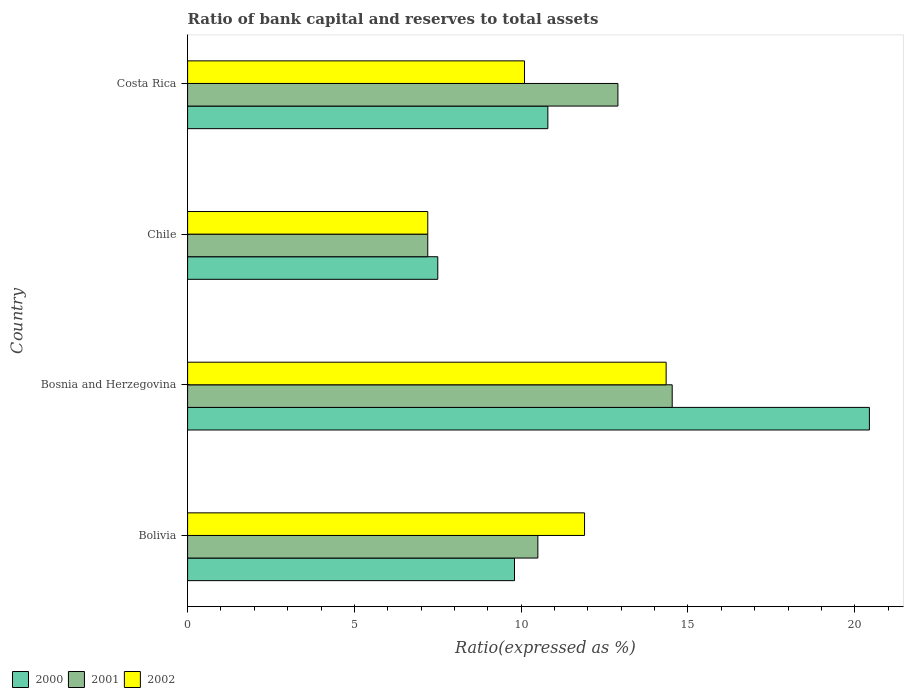How many different coloured bars are there?
Ensure brevity in your answer.  3. How many groups of bars are there?
Keep it short and to the point. 4. Are the number of bars per tick equal to the number of legend labels?
Keep it short and to the point. Yes. How many bars are there on the 4th tick from the bottom?
Keep it short and to the point. 3. What is the label of the 4th group of bars from the top?
Offer a terse response. Bolivia. What is the ratio of bank capital and reserves to total assets in 2000 in Chile?
Provide a short and direct response. 7.5. Across all countries, what is the maximum ratio of bank capital and reserves to total assets in 2002?
Offer a terse response. 14.35. In which country was the ratio of bank capital and reserves to total assets in 2000 maximum?
Keep it short and to the point. Bosnia and Herzegovina. What is the total ratio of bank capital and reserves to total assets in 2001 in the graph?
Ensure brevity in your answer.  45.13. What is the difference between the ratio of bank capital and reserves to total assets in 2000 in Bolivia and that in Costa Rica?
Provide a succinct answer. -1. What is the difference between the ratio of bank capital and reserves to total assets in 2001 in Bosnia and Herzegovina and the ratio of bank capital and reserves to total assets in 2000 in Chile?
Provide a short and direct response. 7.03. What is the average ratio of bank capital and reserves to total assets in 2000 per country?
Your answer should be very brief. 12.13. What is the difference between the ratio of bank capital and reserves to total assets in 2000 and ratio of bank capital and reserves to total assets in 2002 in Costa Rica?
Ensure brevity in your answer.  0.7. In how many countries, is the ratio of bank capital and reserves to total assets in 2000 greater than 15 %?
Ensure brevity in your answer.  1. What is the ratio of the ratio of bank capital and reserves to total assets in 2000 in Bosnia and Herzegovina to that in Costa Rica?
Make the answer very short. 1.89. What is the difference between the highest and the second highest ratio of bank capital and reserves to total assets in 2001?
Ensure brevity in your answer.  1.63. What is the difference between the highest and the lowest ratio of bank capital and reserves to total assets in 2001?
Offer a terse response. 7.33. What does the 1st bar from the top in Costa Rica represents?
Give a very brief answer. 2002. What does the 1st bar from the bottom in Chile represents?
Offer a very short reply. 2000. How many countries are there in the graph?
Your response must be concise. 4. What is the title of the graph?
Provide a short and direct response. Ratio of bank capital and reserves to total assets. What is the label or title of the X-axis?
Provide a succinct answer. Ratio(expressed as %). What is the label or title of the Y-axis?
Provide a short and direct response. Country. What is the Ratio(expressed as %) of 2000 in Bolivia?
Your answer should be compact. 9.8. What is the Ratio(expressed as %) of 2000 in Bosnia and Herzegovina?
Make the answer very short. 20.44. What is the Ratio(expressed as %) of 2001 in Bosnia and Herzegovina?
Your response must be concise. 14.53. What is the Ratio(expressed as %) in 2002 in Bosnia and Herzegovina?
Your answer should be very brief. 14.35. What is the Ratio(expressed as %) of 2002 in Chile?
Provide a succinct answer. 7.2. What is the Ratio(expressed as %) of 2002 in Costa Rica?
Provide a short and direct response. 10.1. Across all countries, what is the maximum Ratio(expressed as %) of 2000?
Your answer should be compact. 20.44. Across all countries, what is the maximum Ratio(expressed as %) in 2001?
Your answer should be very brief. 14.53. Across all countries, what is the maximum Ratio(expressed as %) in 2002?
Ensure brevity in your answer.  14.35. What is the total Ratio(expressed as %) of 2000 in the graph?
Make the answer very short. 48.54. What is the total Ratio(expressed as %) of 2001 in the graph?
Make the answer very short. 45.13. What is the total Ratio(expressed as %) in 2002 in the graph?
Your answer should be very brief. 43.55. What is the difference between the Ratio(expressed as %) in 2000 in Bolivia and that in Bosnia and Herzegovina?
Provide a short and direct response. -10.64. What is the difference between the Ratio(expressed as %) in 2001 in Bolivia and that in Bosnia and Herzegovina?
Provide a short and direct response. -4.03. What is the difference between the Ratio(expressed as %) of 2002 in Bolivia and that in Bosnia and Herzegovina?
Ensure brevity in your answer.  -2.45. What is the difference between the Ratio(expressed as %) in 2001 in Bolivia and that in Chile?
Your answer should be very brief. 3.3. What is the difference between the Ratio(expressed as %) of 2000 in Bosnia and Herzegovina and that in Chile?
Your answer should be very brief. 12.94. What is the difference between the Ratio(expressed as %) of 2001 in Bosnia and Herzegovina and that in Chile?
Give a very brief answer. 7.33. What is the difference between the Ratio(expressed as %) of 2002 in Bosnia and Herzegovina and that in Chile?
Offer a very short reply. 7.15. What is the difference between the Ratio(expressed as %) in 2000 in Bosnia and Herzegovina and that in Costa Rica?
Provide a short and direct response. 9.64. What is the difference between the Ratio(expressed as %) of 2001 in Bosnia and Herzegovina and that in Costa Rica?
Your response must be concise. 1.63. What is the difference between the Ratio(expressed as %) in 2002 in Bosnia and Herzegovina and that in Costa Rica?
Ensure brevity in your answer.  4.25. What is the difference between the Ratio(expressed as %) of 2002 in Chile and that in Costa Rica?
Provide a short and direct response. -2.9. What is the difference between the Ratio(expressed as %) of 2000 in Bolivia and the Ratio(expressed as %) of 2001 in Bosnia and Herzegovina?
Give a very brief answer. -4.73. What is the difference between the Ratio(expressed as %) in 2000 in Bolivia and the Ratio(expressed as %) in 2002 in Bosnia and Herzegovina?
Your response must be concise. -4.55. What is the difference between the Ratio(expressed as %) of 2001 in Bolivia and the Ratio(expressed as %) of 2002 in Bosnia and Herzegovina?
Provide a succinct answer. -3.85. What is the difference between the Ratio(expressed as %) in 2000 in Bolivia and the Ratio(expressed as %) in 2001 in Chile?
Make the answer very short. 2.6. What is the difference between the Ratio(expressed as %) of 2000 in Bolivia and the Ratio(expressed as %) of 2001 in Costa Rica?
Your answer should be very brief. -3.1. What is the difference between the Ratio(expressed as %) in 2000 in Bosnia and Herzegovina and the Ratio(expressed as %) in 2001 in Chile?
Your answer should be very brief. 13.24. What is the difference between the Ratio(expressed as %) in 2000 in Bosnia and Herzegovina and the Ratio(expressed as %) in 2002 in Chile?
Keep it short and to the point. 13.24. What is the difference between the Ratio(expressed as %) of 2001 in Bosnia and Herzegovina and the Ratio(expressed as %) of 2002 in Chile?
Provide a succinct answer. 7.33. What is the difference between the Ratio(expressed as %) in 2000 in Bosnia and Herzegovina and the Ratio(expressed as %) in 2001 in Costa Rica?
Give a very brief answer. 7.54. What is the difference between the Ratio(expressed as %) in 2000 in Bosnia and Herzegovina and the Ratio(expressed as %) in 2002 in Costa Rica?
Make the answer very short. 10.34. What is the difference between the Ratio(expressed as %) in 2001 in Bosnia and Herzegovina and the Ratio(expressed as %) in 2002 in Costa Rica?
Your answer should be compact. 4.43. What is the difference between the Ratio(expressed as %) of 2000 in Chile and the Ratio(expressed as %) of 2001 in Costa Rica?
Offer a terse response. -5.4. What is the difference between the Ratio(expressed as %) in 2001 in Chile and the Ratio(expressed as %) in 2002 in Costa Rica?
Provide a succinct answer. -2.9. What is the average Ratio(expressed as %) of 2000 per country?
Your response must be concise. 12.13. What is the average Ratio(expressed as %) of 2001 per country?
Provide a short and direct response. 11.28. What is the average Ratio(expressed as %) in 2002 per country?
Your response must be concise. 10.89. What is the difference between the Ratio(expressed as %) in 2000 and Ratio(expressed as %) in 2001 in Bolivia?
Your answer should be very brief. -0.7. What is the difference between the Ratio(expressed as %) of 2000 and Ratio(expressed as %) of 2002 in Bolivia?
Ensure brevity in your answer.  -2.1. What is the difference between the Ratio(expressed as %) in 2001 and Ratio(expressed as %) in 2002 in Bolivia?
Keep it short and to the point. -1.4. What is the difference between the Ratio(expressed as %) in 2000 and Ratio(expressed as %) in 2001 in Bosnia and Herzegovina?
Provide a short and direct response. 5.91. What is the difference between the Ratio(expressed as %) in 2000 and Ratio(expressed as %) in 2002 in Bosnia and Herzegovina?
Offer a terse response. 6.09. What is the difference between the Ratio(expressed as %) in 2001 and Ratio(expressed as %) in 2002 in Bosnia and Herzegovina?
Provide a succinct answer. 0.18. What is the ratio of the Ratio(expressed as %) in 2000 in Bolivia to that in Bosnia and Herzegovina?
Give a very brief answer. 0.48. What is the ratio of the Ratio(expressed as %) in 2001 in Bolivia to that in Bosnia and Herzegovina?
Offer a very short reply. 0.72. What is the ratio of the Ratio(expressed as %) in 2002 in Bolivia to that in Bosnia and Herzegovina?
Ensure brevity in your answer.  0.83. What is the ratio of the Ratio(expressed as %) of 2000 in Bolivia to that in Chile?
Offer a terse response. 1.31. What is the ratio of the Ratio(expressed as %) of 2001 in Bolivia to that in Chile?
Your answer should be compact. 1.46. What is the ratio of the Ratio(expressed as %) of 2002 in Bolivia to that in Chile?
Ensure brevity in your answer.  1.65. What is the ratio of the Ratio(expressed as %) in 2000 in Bolivia to that in Costa Rica?
Your response must be concise. 0.91. What is the ratio of the Ratio(expressed as %) in 2001 in Bolivia to that in Costa Rica?
Offer a very short reply. 0.81. What is the ratio of the Ratio(expressed as %) of 2002 in Bolivia to that in Costa Rica?
Give a very brief answer. 1.18. What is the ratio of the Ratio(expressed as %) of 2000 in Bosnia and Herzegovina to that in Chile?
Provide a short and direct response. 2.73. What is the ratio of the Ratio(expressed as %) of 2001 in Bosnia and Herzegovina to that in Chile?
Make the answer very short. 2.02. What is the ratio of the Ratio(expressed as %) of 2002 in Bosnia and Herzegovina to that in Chile?
Offer a terse response. 1.99. What is the ratio of the Ratio(expressed as %) of 2000 in Bosnia and Herzegovina to that in Costa Rica?
Your answer should be very brief. 1.89. What is the ratio of the Ratio(expressed as %) in 2001 in Bosnia and Herzegovina to that in Costa Rica?
Provide a succinct answer. 1.13. What is the ratio of the Ratio(expressed as %) of 2002 in Bosnia and Herzegovina to that in Costa Rica?
Offer a very short reply. 1.42. What is the ratio of the Ratio(expressed as %) in 2000 in Chile to that in Costa Rica?
Provide a short and direct response. 0.69. What is the ratio of the Ratio(expressed as %) in 2001 in Chile to that in Costa Rica?
Your response must be concise. 0.56. What is the ratio of the Ratio(expressed as %) in 2002 in Chile to that in Costa Rica?
Make the answer very short. 0.71. What is the difference between the highest and the second highest Ratio(expressed as %) in 2000?
Ensure brevity in your answer.  9.64. What is the difference between the highest and the second highest Ratio(expressed as %) in 2001?
Provide a succinct answer. 1.63. What is the difference between the highest and the second highest Ratio(expressed as %) in 2002?
Give a very brief answer. 2.45. What is the difference between the highest and the lowest Ratio(expressed as %) in 2000?
Give a very brief answer. 12.94. What is the difference between the highest and the lowest Ratio(expressed as %) of 2001?
Give a very brief answer. 7.33. What is the difference between the highest and the lowest Ratio(expressed as %) of 2002?
Offer a very short reply. 7.15. 